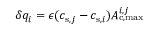Convert formula to latex. <formula><loc_0><loc_0><loc_500><loc_500>\delta q _ { i } = \epsilon ( c _ { s , j } - c _ { s , i } ) A _ { c , \max } ^ { i , j }</formula> 